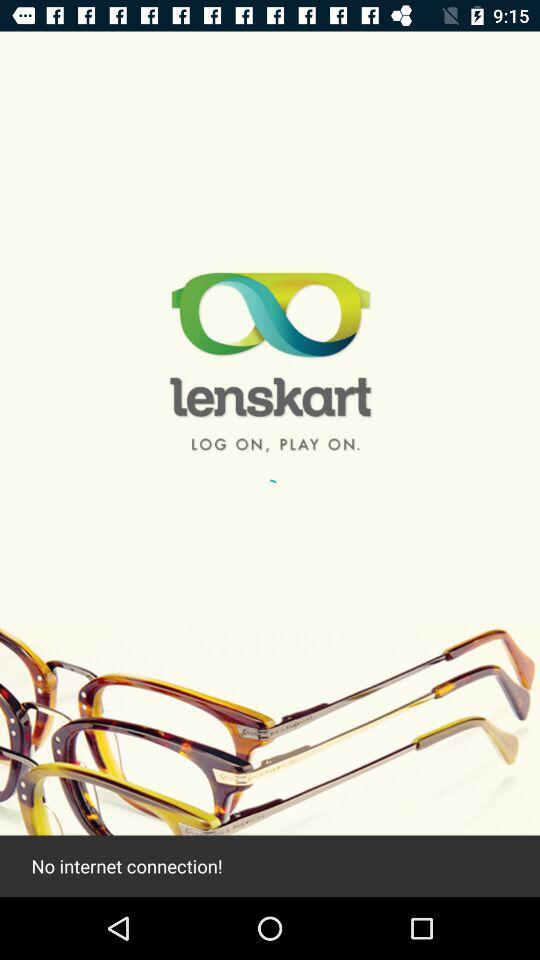Which internet connection failed to connect?
When the provided information is insufficient, respond with <no answer>. <no answer> 